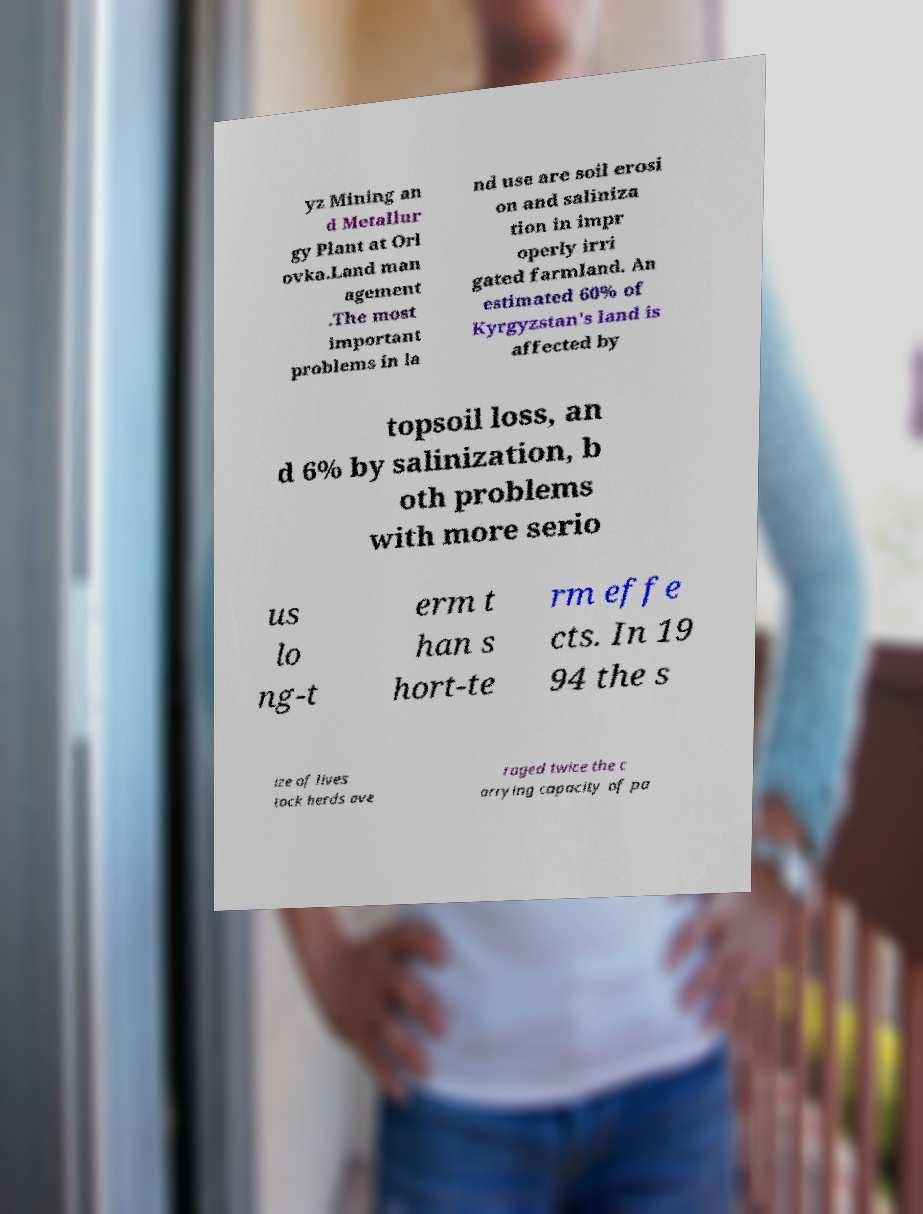There's text embedded in this image that I need extracted. Can you transcribe it verbatim? yz Mining an d Metallur gy Plant at Orl ovka.Land man agement .The most important problems in la nd use are soil erosi on and saliniza tion in impr operly irri gated farmland. An estimated 60% of Kyrgyzstan's land is affected by topsoil loss, an d 6% by salinization, b oth problems with more serio us lo ng-t erm t han s hort-te rm effe cts. In 19 94 the s ize of lives tock herds ave raged twice the c arrying capacity of pa 